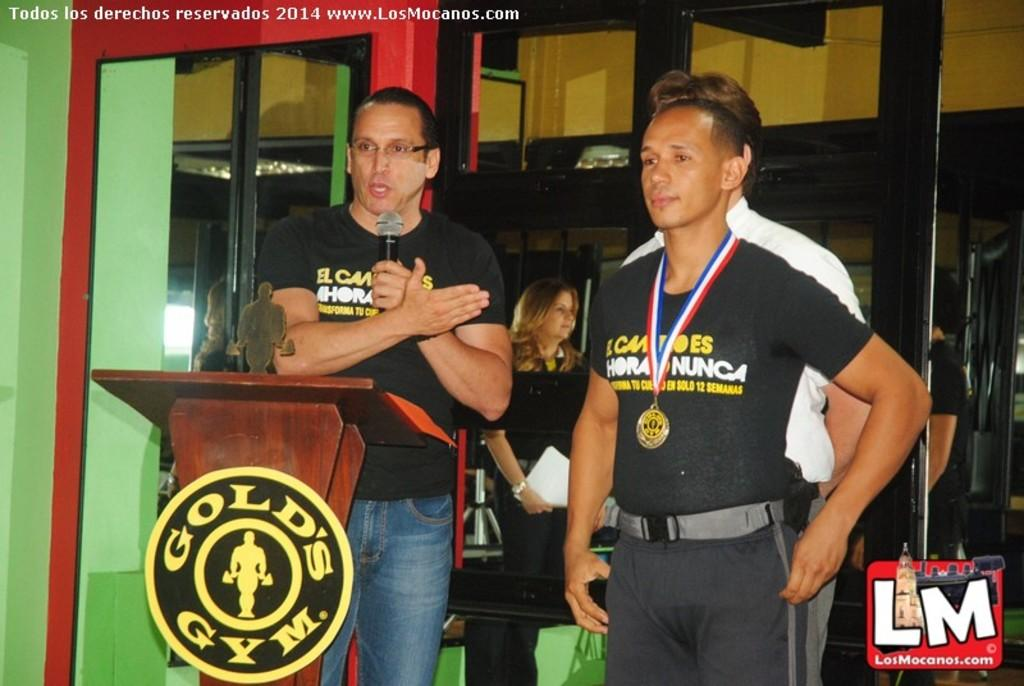<image>
Create a compact narrative representing the image presented. Two men speaking in front of a podium which says Gold's Gym. 